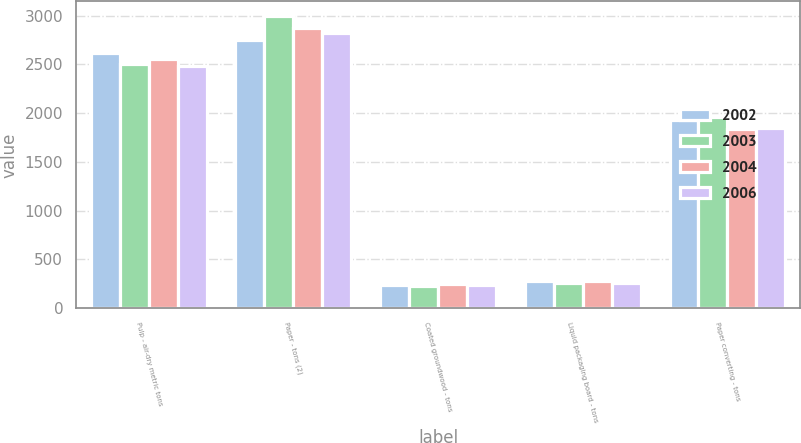<chart> <loc_0><loc_0><loc_500><loc_500><stacked_bar_chart><ecel><fcel>Pulp - air-dry metric tons<fcel>Paper - tons (2)<fcel>Coated groundwood - tons<fcel>Liquid packaging board - tons<fcel>Paper converting - tons<nl><fcel>2002<fcel>2621<fcel>2749<fcel>234<fcel>275<fcel>1932<nl><fcel>2003<fcel>2502<fcel>2996<fcel>232<fcel>258<fcel>1964<nl><fcel>2004<fcel>2558<fcel>2876<fcel>243<fcel>276<fcel>1839<nl><fcel>2006<fcel>2479<fcel>2822<fcel>234<fcel>256<fcel>1847<nl></chart> 